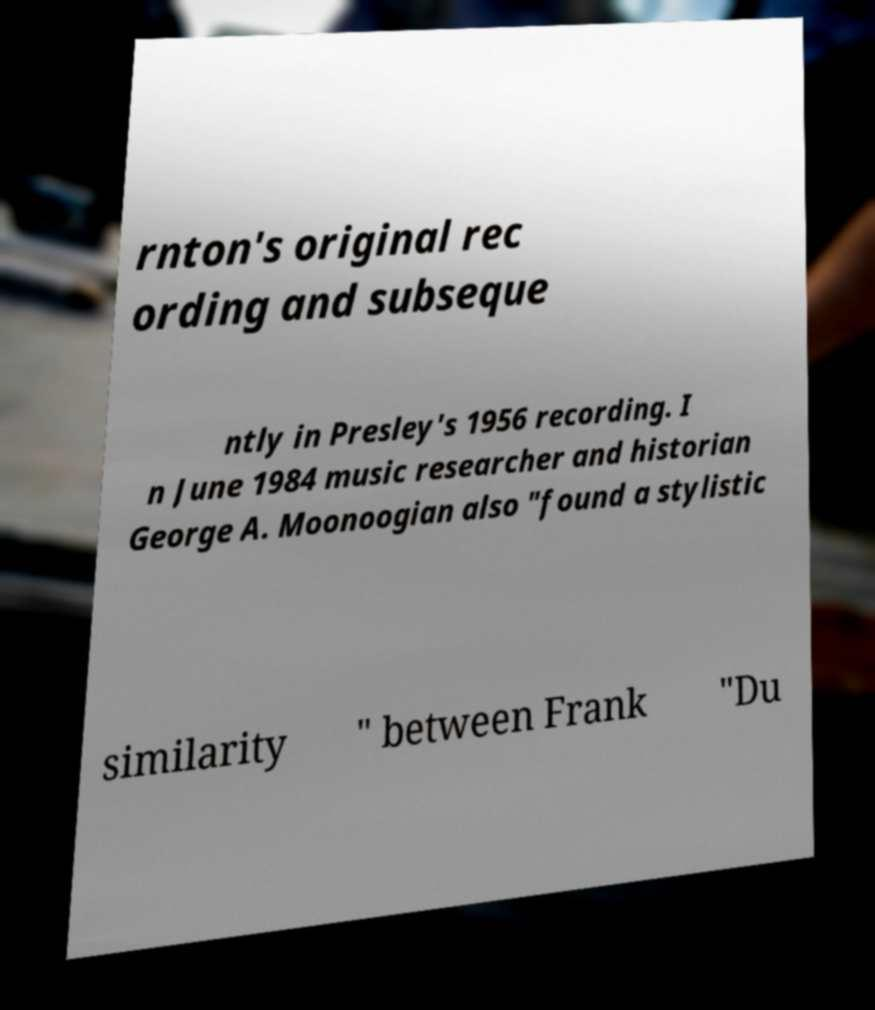Could you assist in decoding the text presented in this image and type it out clearly? rnton's original rec ording and subseque ntly in Presley's 1956 recording. I n June 1984 music researcher and historian George A. Moonoogian also "found a stylistic similarity " between Frank "Du 